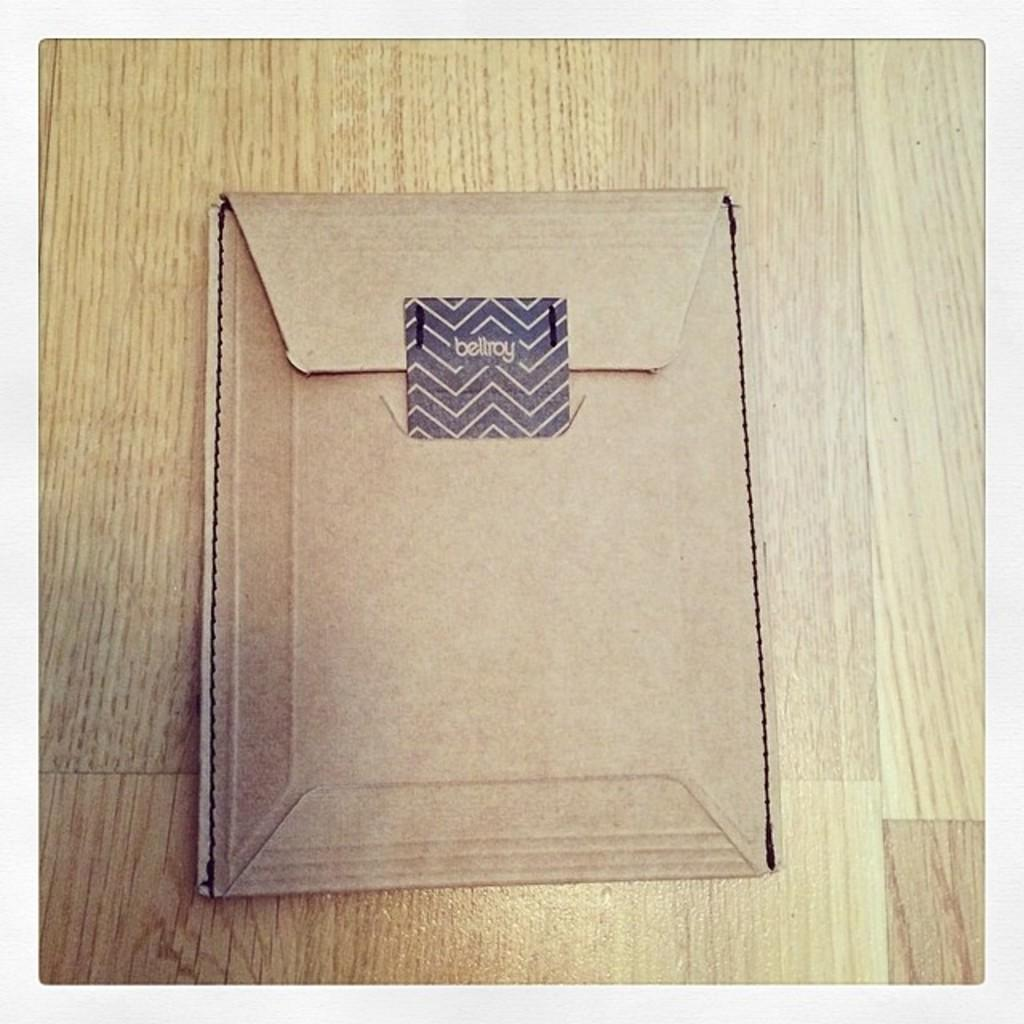<image>
Offer a succinct explanation of the picture presented. a brown paper package is sealed with a bellroy seal 